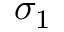<formula> <loc_0><loc_0><loc_500><loc_500>\sigma _ { 1 }</formula> 